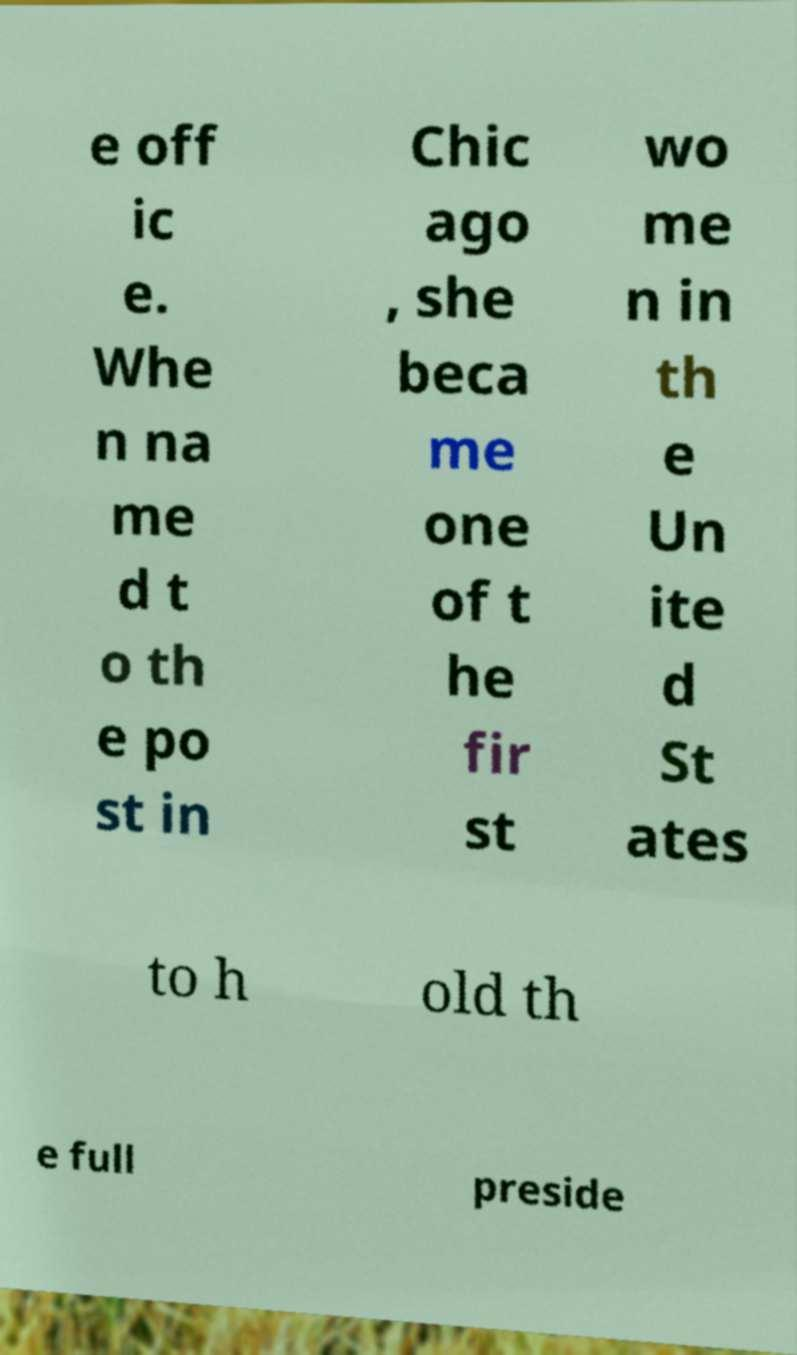Can you accurately transcribe the text from the provided image for me? e off ic e. Whe n na me d t o th e po st in Chic ago , she beca me one of t he fir st wo me n in th e Un ite d St ates to h old th e full preside 